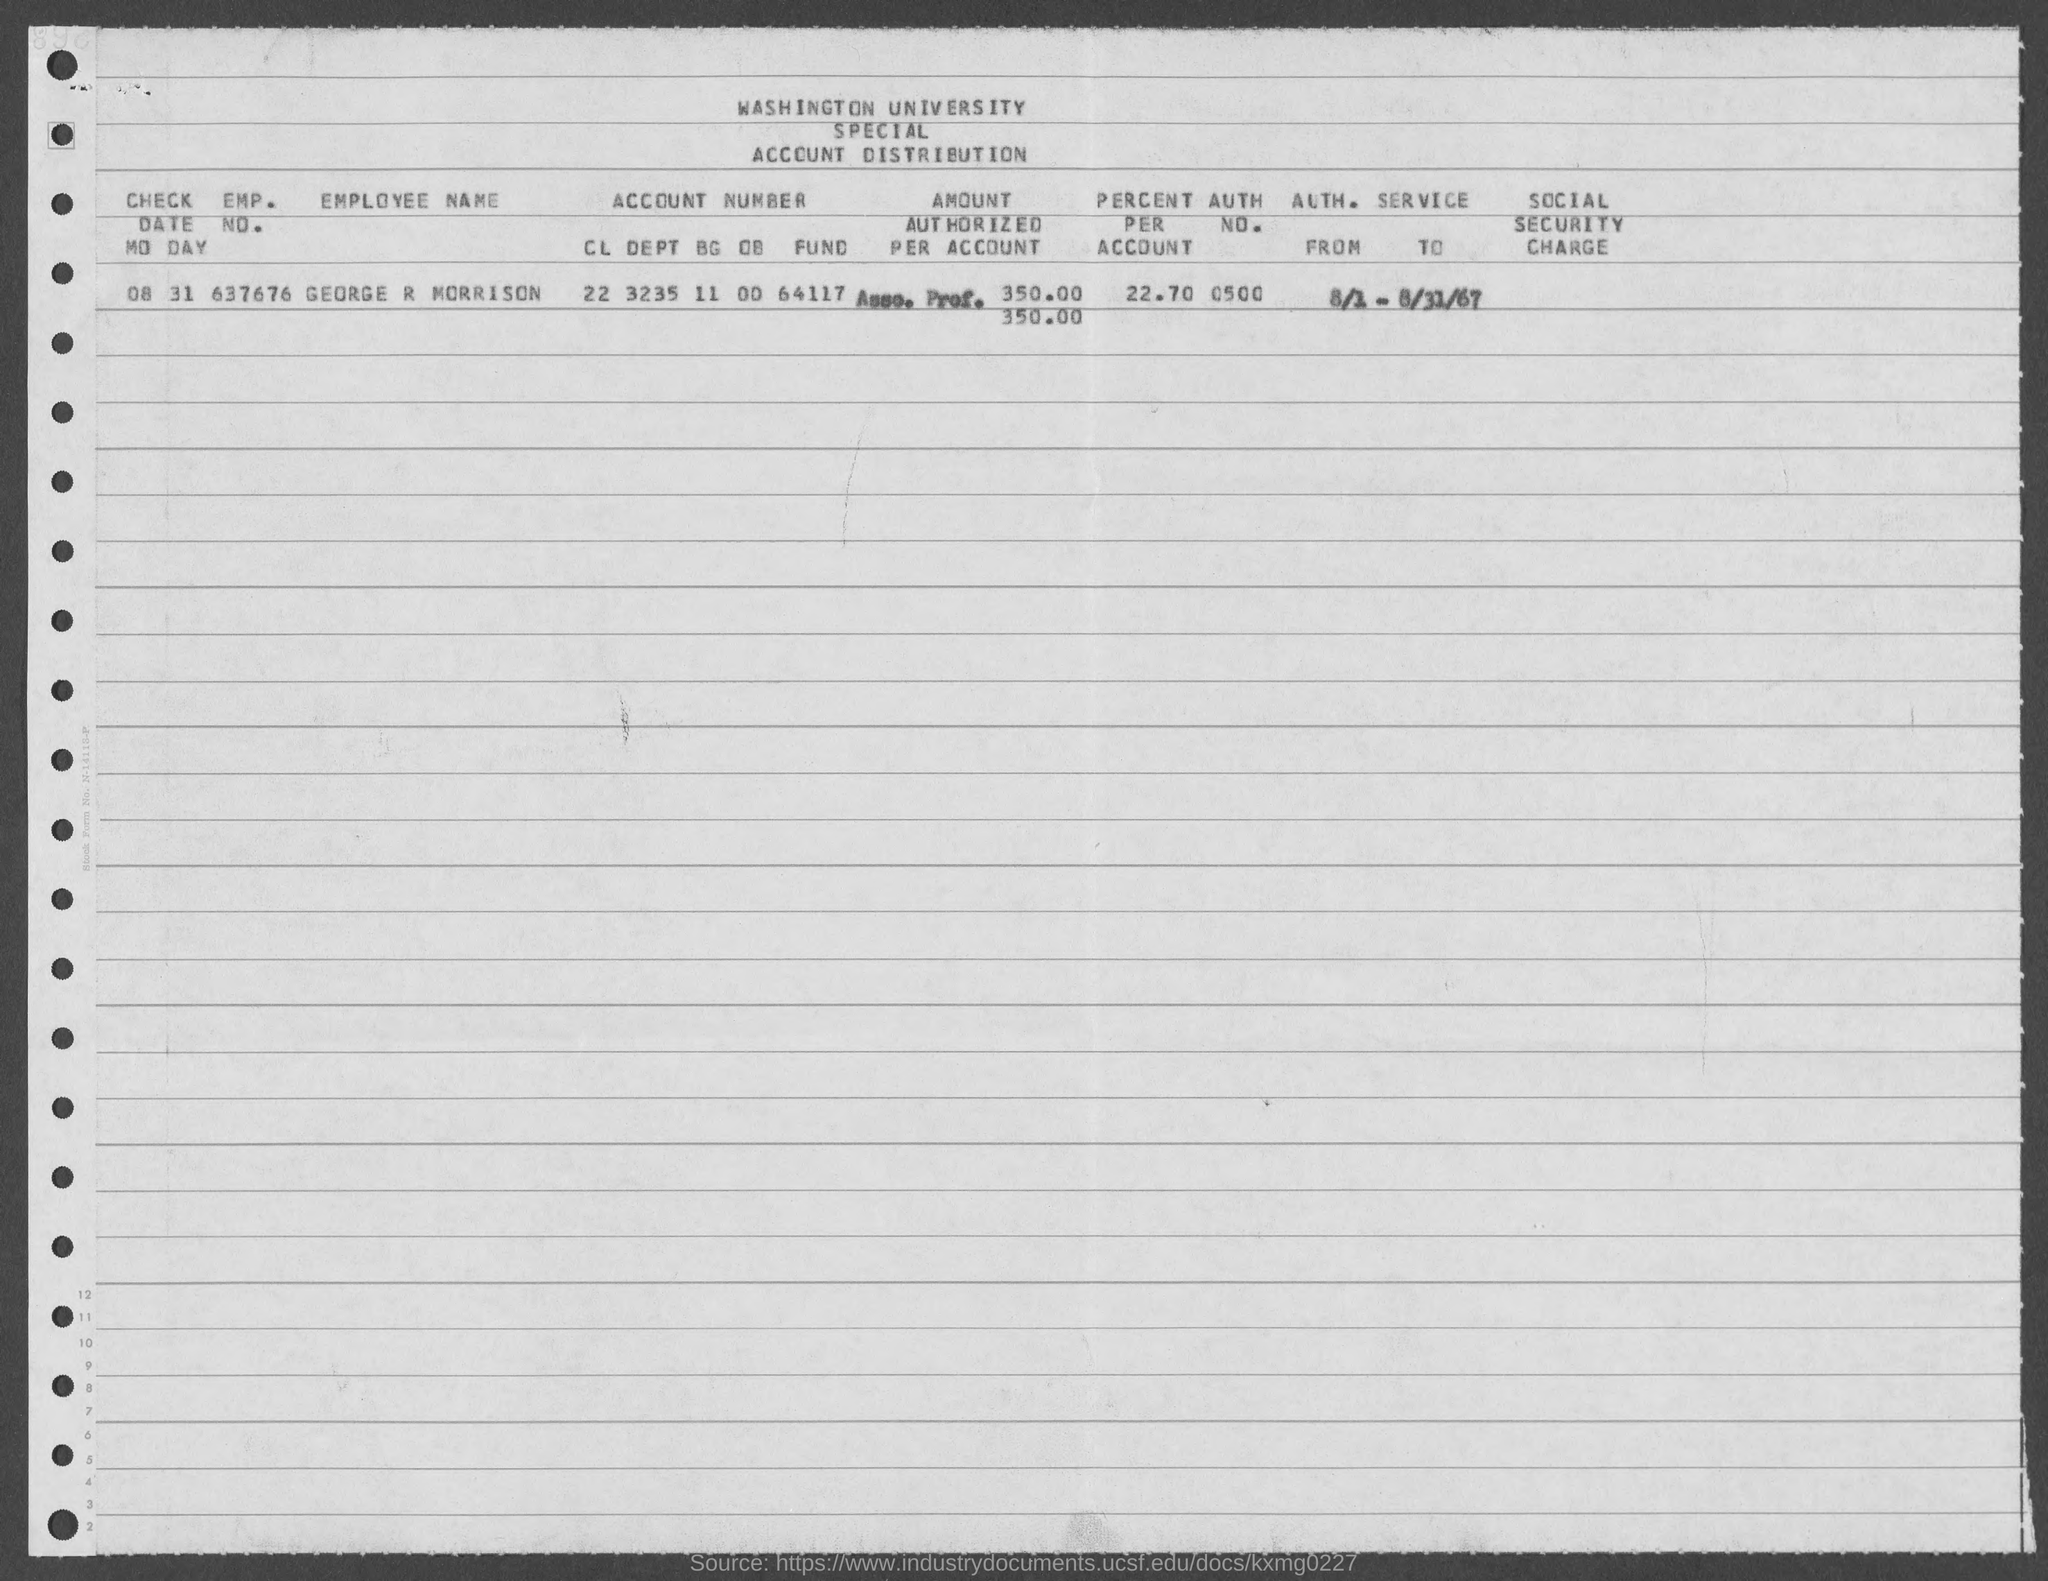What is the employee name mentioned in the given form ?
Your answer should be very brief. George r Morrison. What is the emp. no. mentioned in the given form ?
Your response must be concise. 637676. What is the auth. no. mentioned in the given form ?
Provide a short and direct response. 0500. What is the check date mentioned in the given form ?
Offer a very short reply. 08 31. What is the value of percent per account as mentioned in the given form ?
Offer a very short reply. 22.70. 